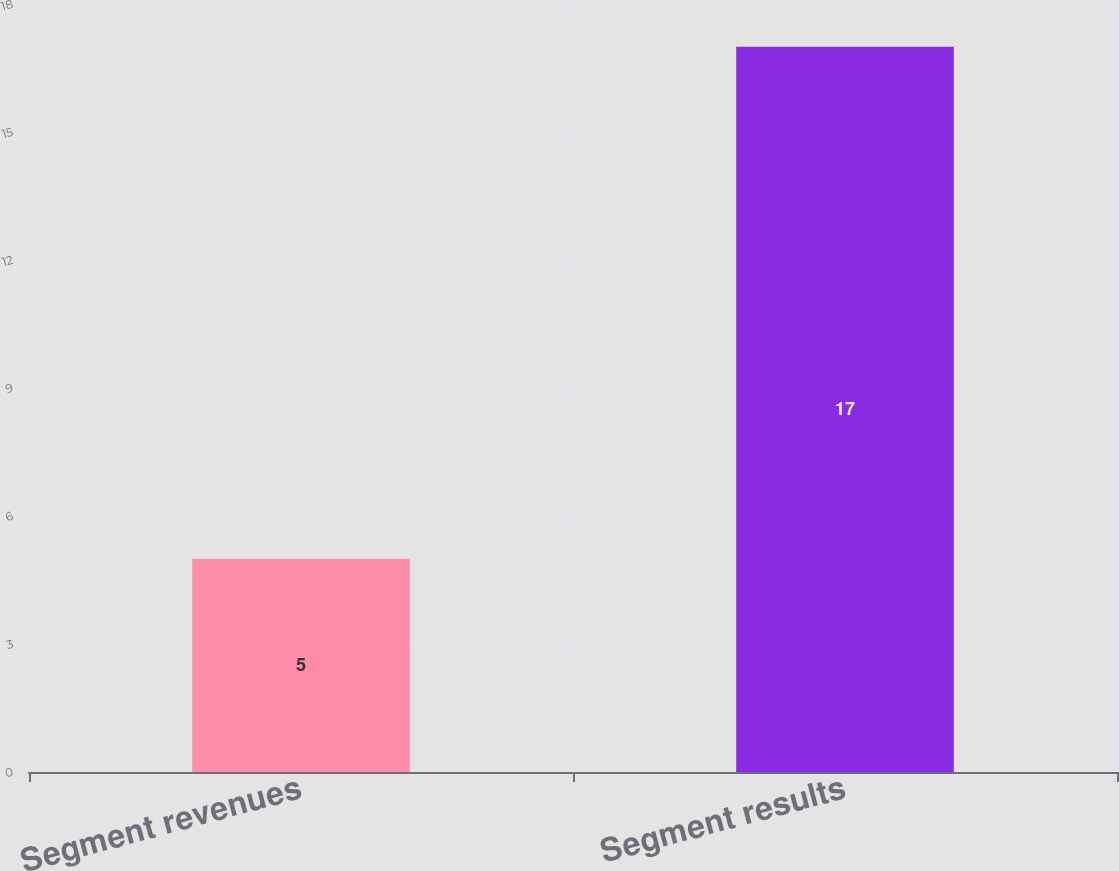Convert chart. <chart><loc_0><loc_0><loc_500><loc_500><bar_chart><fcel>Segment revenues<fcel>Segment results<nl><fcel>5<fcel>17<nl></chart> 